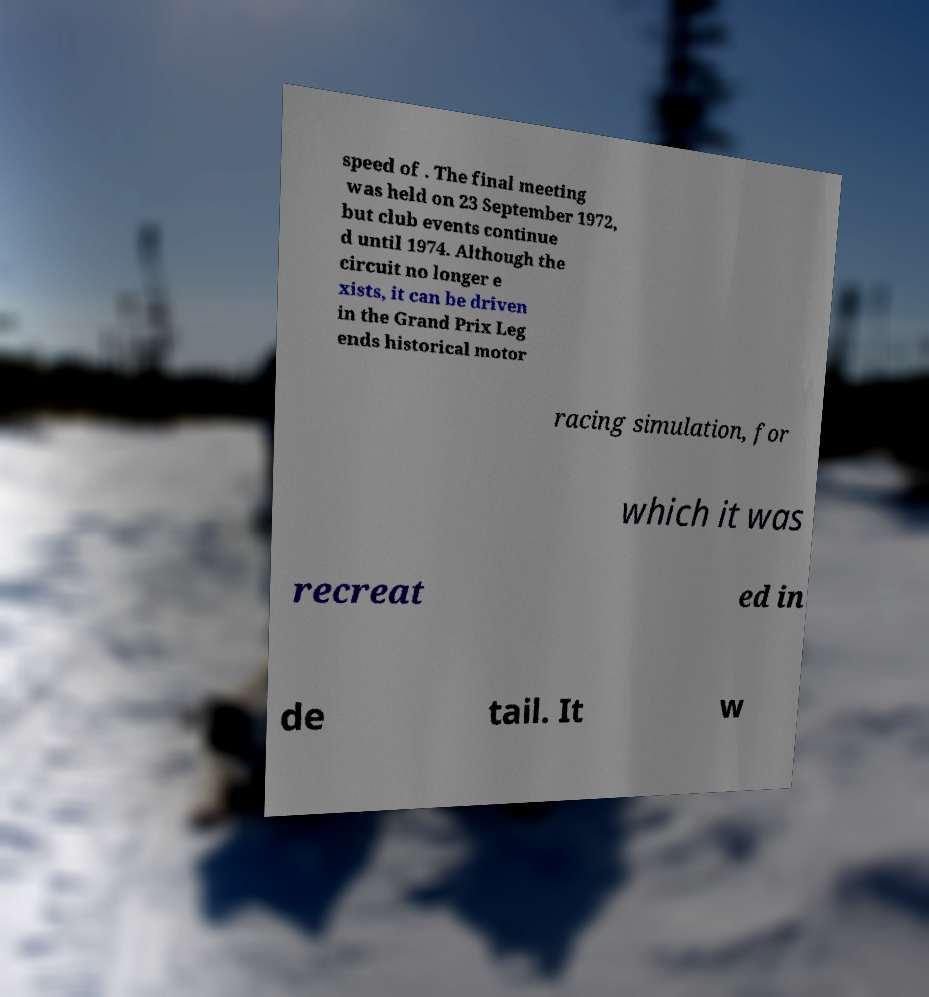For documentation purposes, I need the text within this image transcribed. Could you provide that? speed of . The final meeting was held on 23 September 1972, but club events continue d until 1974. Although the circuit no longer e xists, it can be driven in the Grand Prix Leg ends historical motor racing simulation, for which it was recreat ed in de tail. It w 